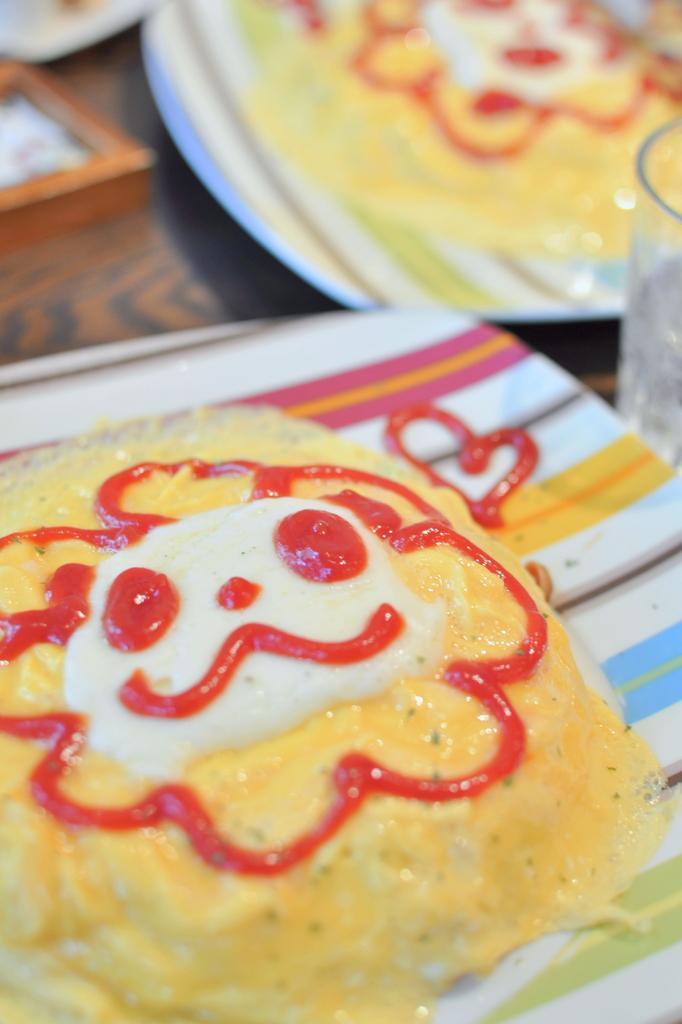Please provide a concise description of this image. There are plates on a surface. On the plates there are some food items. On the food item there is sauce and some other things. 